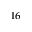<formula> <loc_0><loc_0><loc_500><loc_500>^ { 1 6 }</formula> 